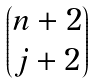Convert formula to latex. <formula><loc_0><loc_0><loc_500><loc_500>\begin{pmatrix} n + 2 \\ j + 2 \end{pmatrix}</formula> 